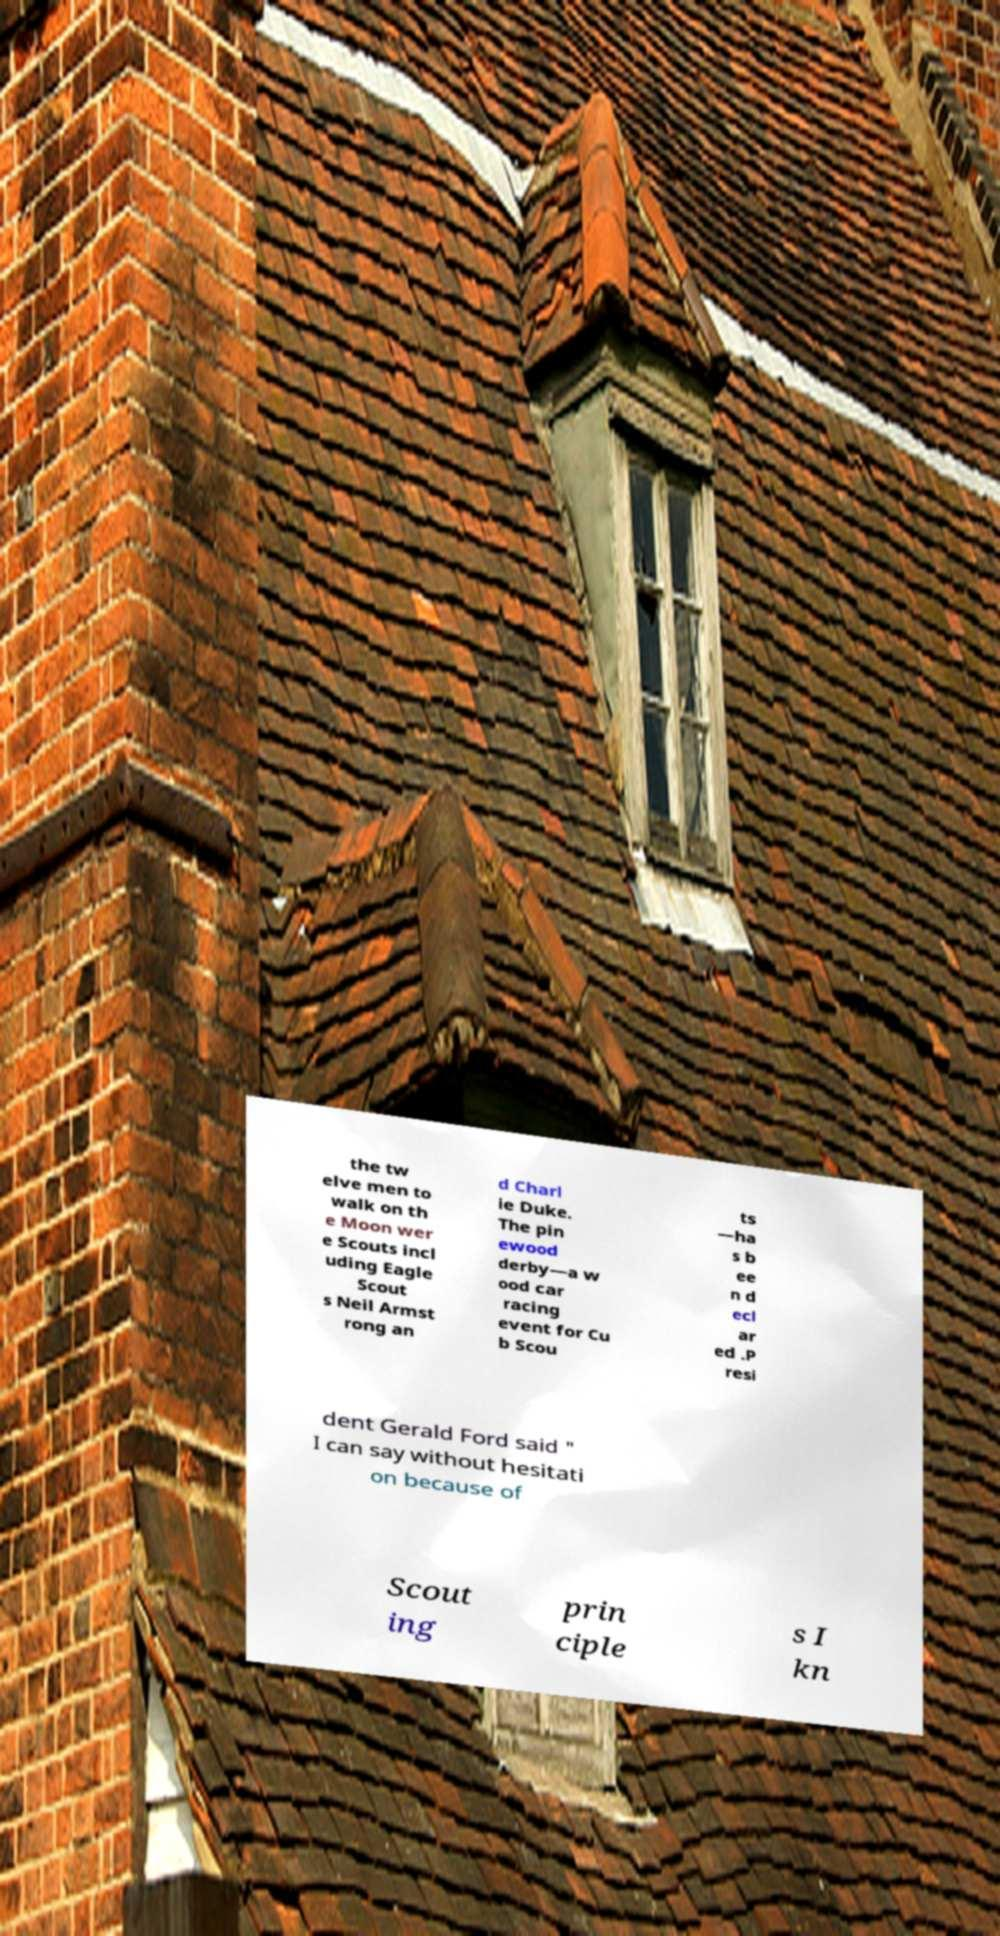Can you read and provide the text displayed in the image?This photo seems to have some interesting text. Can you extract and type it out for me? the tw elve men to walk on th e Moon wer e Scouts incl uding Eagle Scout s Neil Armst rong an d Charl ie Duke. The pin ewood derby—a w ood car racing event for Cu b Scou ts —ha s b ee n d ecl ar ed .P resi dent Gerald Ford said " I can say without hesitati on because of Scout ing prin ciple s I kn 